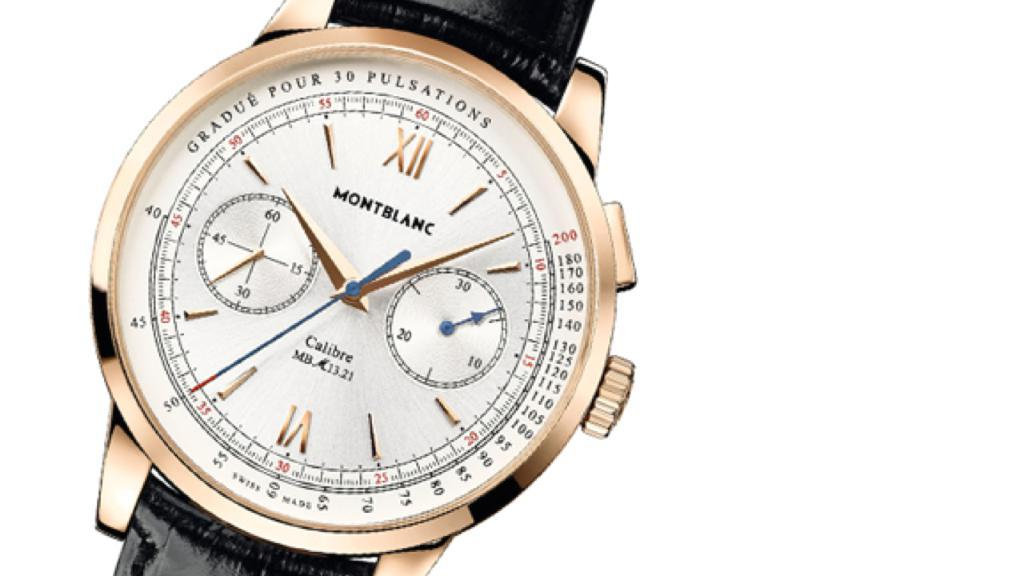Provide a one-sentence caption for the provided image. A black and gold wristwatch from Montblanc watch co. 